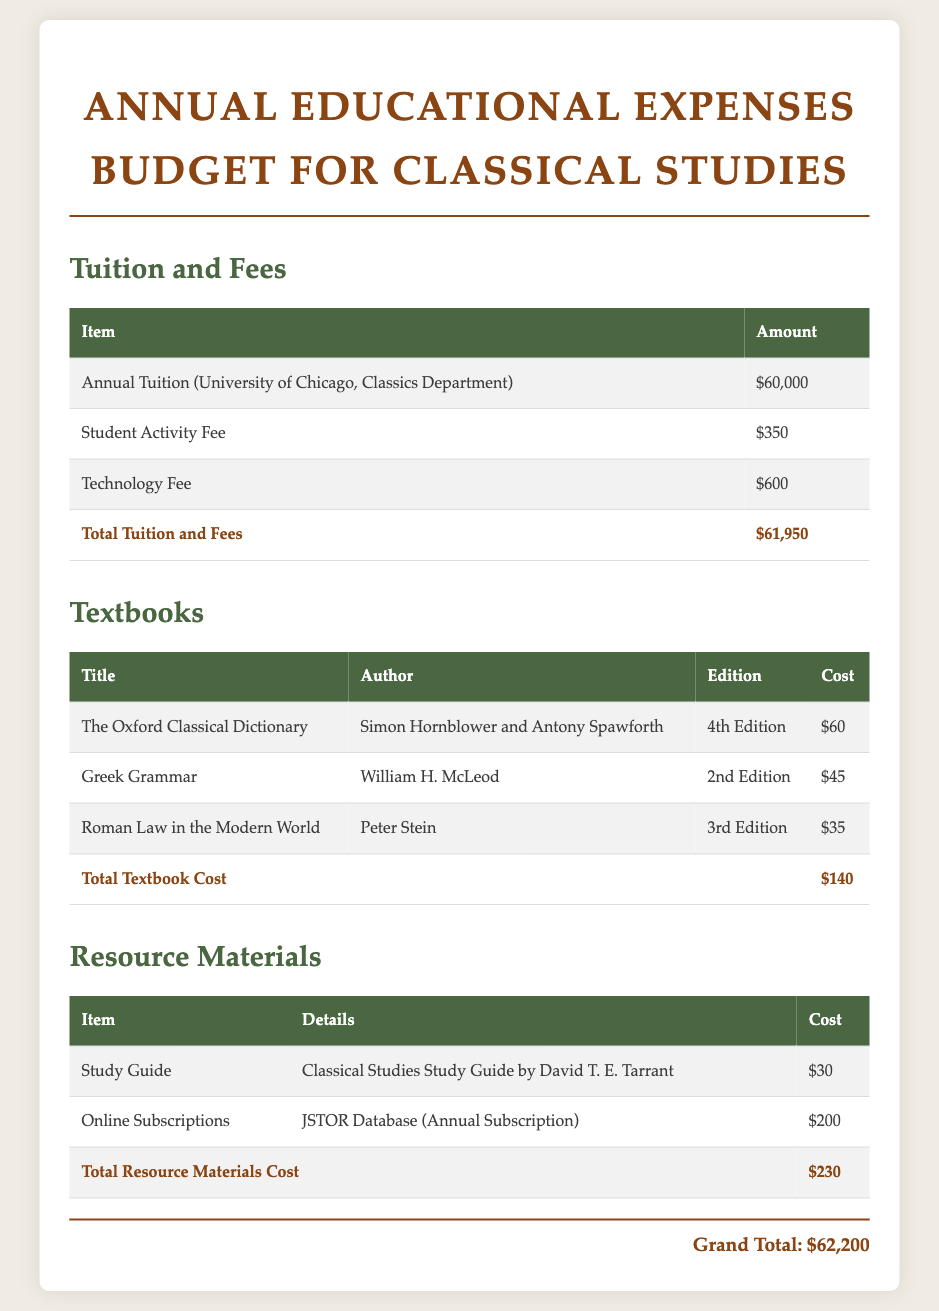What is the total tuition and fees? The total tuition and fees is listed at the bottom of the Tuition and Fees section, which includes annual tuition and additional fees.
Answer: $61,950 Who are the authors of "The Oxford Classical Dictionary"? The authors are specified in the Textbooks section.
Answer: Simon Hornblower and Antony Spawforth What is the cost of the "Greek Grammar" textbook? The cost is provided next to the title in the Textbooks section.
Answer: $45 What is the edition of "Roman Law in the Modern World"? The edition is mentioned in the Textbooks section along with the title and author.
Answer: 3rd Edition What is the total cost for resource materials? The total is calculated in the Resource Materials section and is displayed at the bottom.
Answer: $230 How much does the Technology Fee amount to? The Technology Fee is listed in the Tuition and Fees section.
Answer: $600 What is the grand total for all educational expenses? The grand total is provided at the bottom of the document, summarizing all costs.
Answer: $62,200 What type of subscription is included in the resource materials? The type of subscription is stated in the Resource Materials section.
Answer: JSTOR Database (Annual Subscription) What title is associated with the study guide? The title of the study guide is mentioned in the Resource Materials section.
Answer: Classical Studies Study Guide by David T. E. Tarrant 